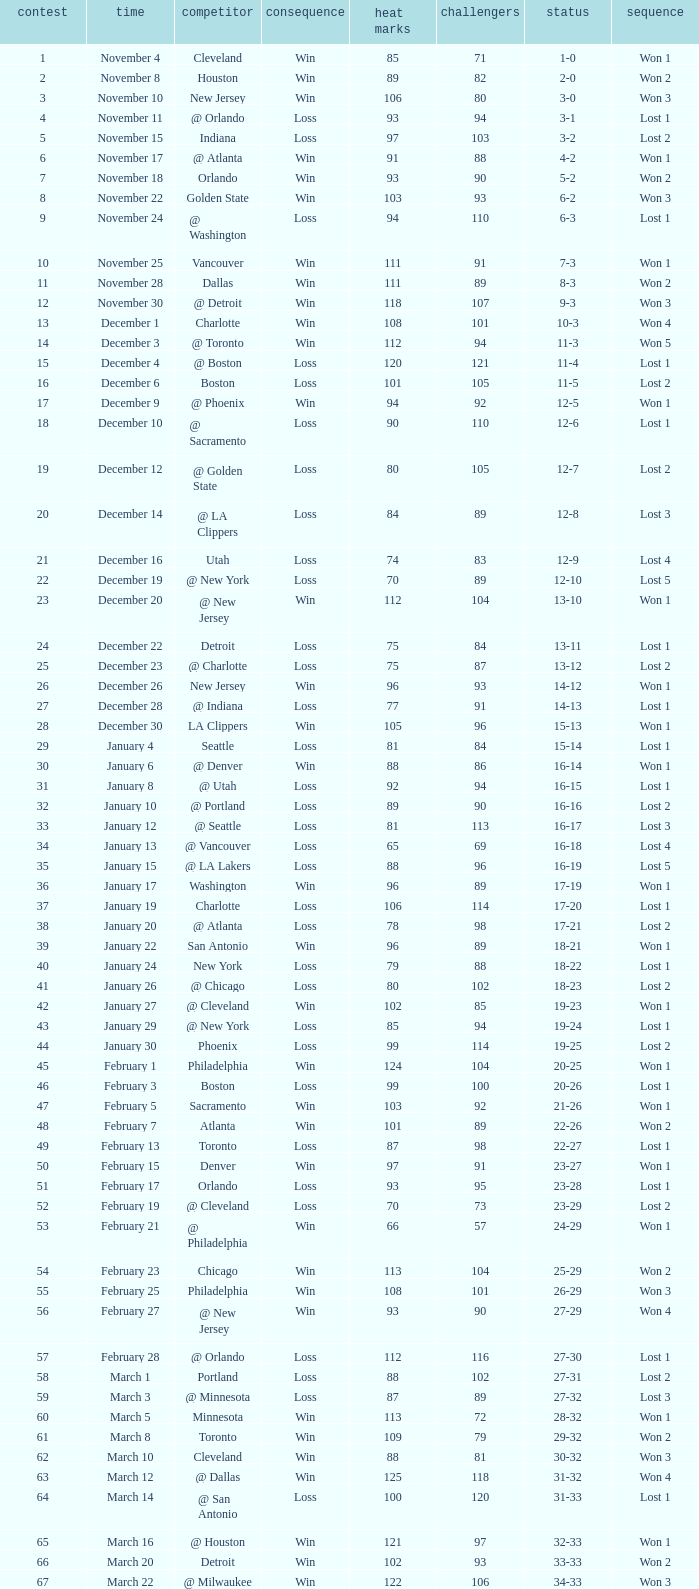What is Streak, when Heat Points is "101", and when Game is "16"? Lost 2. 